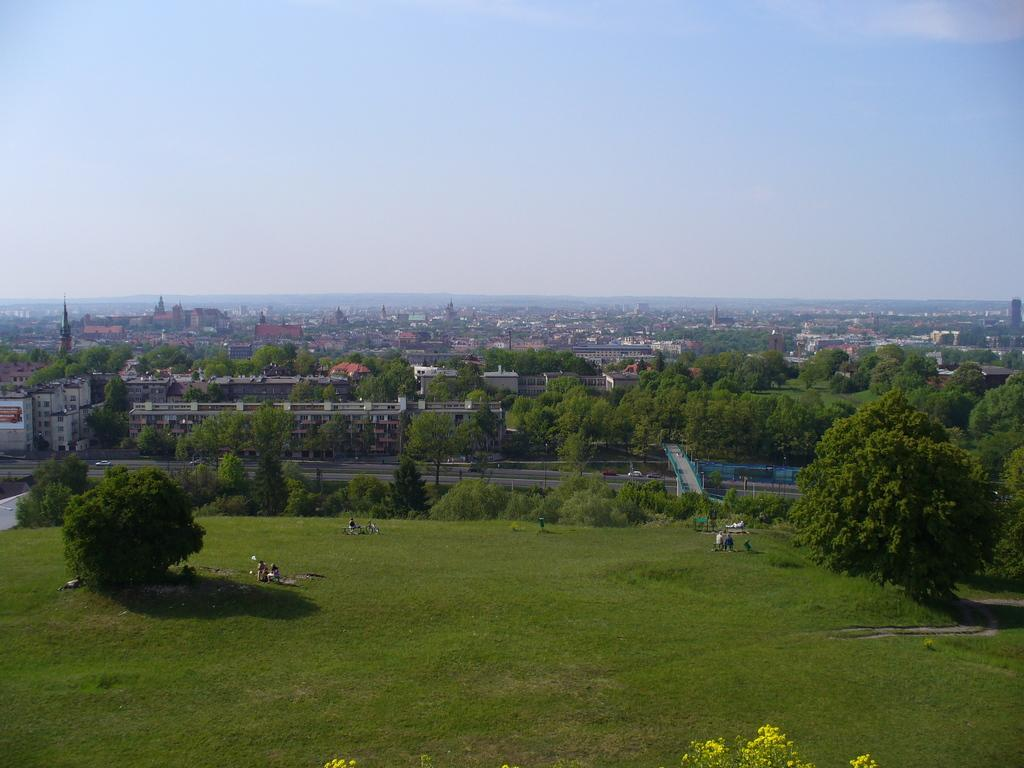What type of natural vegetation can be seen in the image? There are trees in the image. What type of man-made structures are present in the image? There are buildings and towers in the image. What type of geographical feature is visible in the image? There are hills in the image. What part of the natural environment is visible in the image? The sky is visible in the image. What is present at the bottom of the image? There are people and grass at the bottom of the image. What type of ornament is hanging from the trees in the image? There is no ornament hanging from the trees in the image; only trees, buildings, towers, hills, sky, people, and grass are present. What type of linen is draped over the hills in the image? There is no linen draped over the hills in the image; only trees, buildings, towers, hills, sky, people, and grass are present. 